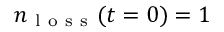Convert formula to latex. <formula><loc_0><loc_0><loc_500><loc_500>n _ { l o s s } ( t = 0 ) = 1</formula> 